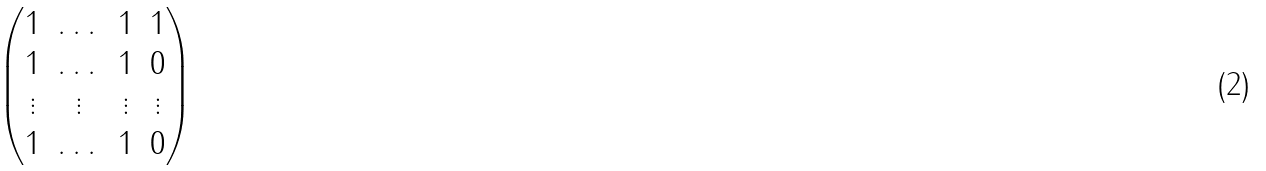Convert formula to latex. <formula><loc_0><loc_0><loc_500><loc_500>\begin{pmatrix} 1 & \dots & 1 & 1 \\ 1 & \dots & 1 & 0 \\ \vdots & \vdots & \vdots & \vdots \\ 1 & \dots & 1 & 0 \end{pmatrix}</formula> 